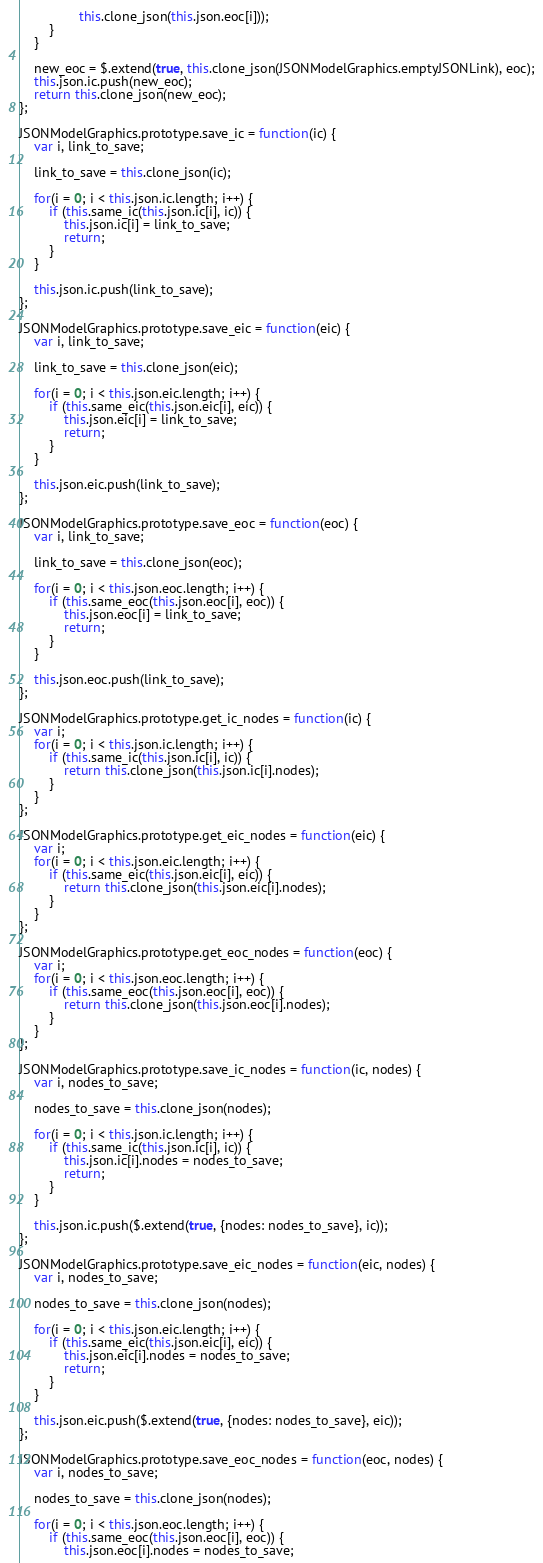Convert code to text. <code><loc_0><loc_0><loc_500><loc_500><_JavaScript_>                this.clone_json(this.json.eoc[i]));
        }
    }

    new_eoc = $.extend(true, this.clone_json(JSONModelGraphics.emptyJSONLink), eoc);
    this.json.ic.push(new_eoc);
    return this.clone_json(new_eoc);
};

JSONModelGraphics.prototype.save_ic = function(ic) {
    var i, link_to_save;

    link_to_save = this.clone_json(ic);

    for(i = 0; i < this.json.ic.length; i++) {
        if (this.same_ic(this.json.ic[i], ic)) {
            this.json.ic[i] = link_to_save;
            return;
        }
    }

    this.json.ic.push(link_to_save);
};

JSONModelGraphics.prototype.save_eic = function(eic) {
    var i, link_to_save;

    link_to_save = this.clone_json(eic);

    for(i = 0; i < this.json.eic.length; i++) {
        if (this.same_eic(this.json.eic[i], eic)) {
            this.json.eic[i] = link_to_save;
            return;
        }
    }

    this.json.eic.push(link_to_save);
};

JSONModelGraphics.prototype.save_eoc = function(eoc) {
    var i, link_to_save;

    link_to_save = this.clone_json(eoc);

    for(i = 0; i < this.json.eoc.length; i++) {
        if (this.same_eoc(this.json.eoc[i], eoc)) {
            this.json.eoc[i] = link_to_save;
            return;
        }
    }

    this.json.eoc.push(link_to_save);
};

JSONModelGraphics.prototype.get_ic_nodes = function(ic) {
    var i;
    for(i = 0; i < this.json.ic.length; i++) {
        if (this.same_ic(this.json.ic[i], ic)) {
            return this.clone_json(this.json.ic[i].nodes);
        }
    }
};

JSONModelGraphics.prototype.get_eic_nodes = function(eic) {
    var i;
    for(i = 0; i < this.json.eic.length; i++) {
        if (this.same_eic(this.json.eic[i], eic)) {
            return this.clone_json(this.json.eic[i].nodes);
        }
    }
};

JSONModelGraphics.prototype.get_eoc_nodes = function(eoc) {
    var i;
    for(i = 0; i < this.json.eoc.length; i++) {
        if (this.same_eoc(this.json.eoc[i], eoc)) {
            return this.clone_json(this.json.eoc[i].nodes);
        }
    }
};

JSONModelGraphics.prototype.save_ic_nodes = function(ic, nodes) {
    var i, nodes_to_save;

    nodes_to_save = this.clone_json(nodes);

    for(i = 0; i < this.json.ic.length; i++) {
        if (this.same_ic(this.json.ic[i], ic)) {
            this.json.ic[i].nodes = nodes_to_save;
            return;
        }
    }

    this.json.ic.push($.extend(true, {nodes: nodes_to_save}, ic));
};

JSONModelGraphics.prototype.save_eic_nodes = function(eic, nodes) {
    var i, nodes_to_save;

    nodes_to_save = this.clone_json(nodes);

    for(i = 0; i < this.json.eic.length; i++) {
        if (this.same_eic(this.json.eic[i], eic)) {
            this.json.eic[i].nodes = nodes_to_save;
            return;
        }
    }

    this.json.eic.push($.extend(true, {nodes: nodes_to_save}, eic));
};

JSONModelGraphics.prototype.save_eoc_nodes = function(eoc, nodes) {
    var i, nodes_to_save;

    nodes_to_save = this.clone_json(nodes);

    for(i = 0; i < this.json.eoc.length; i++) {
        if (this.same_eoc(this.json.eoc[i], eoc)) {
            this.json.eoc[i].nodes = nodes_to_save;</code> 